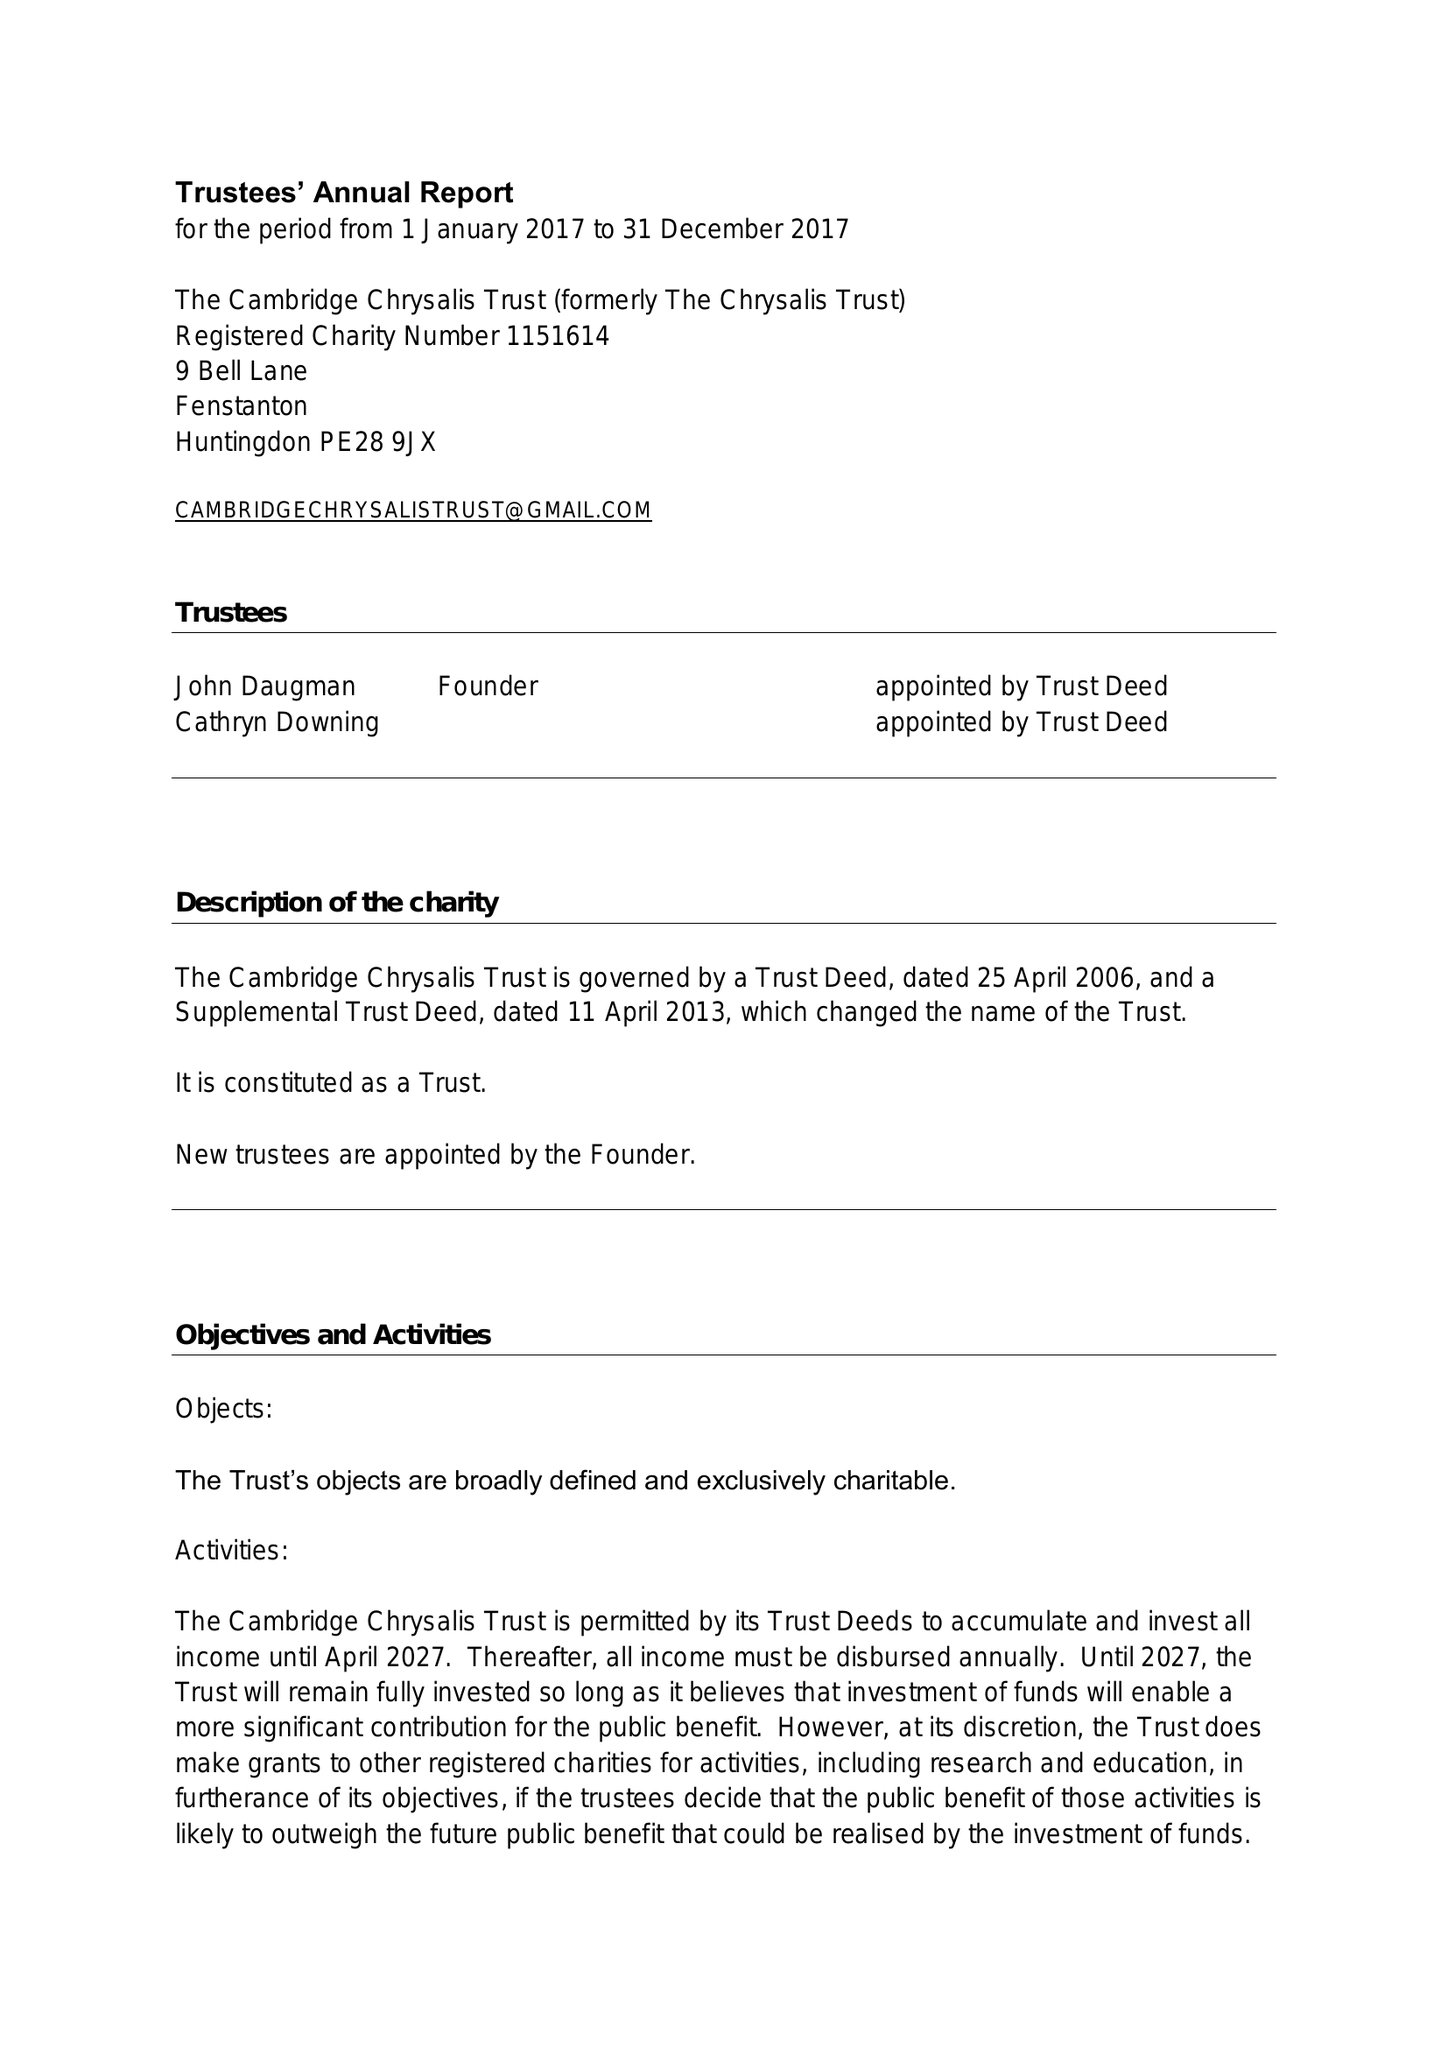What is the value for the charity_name?
Answer the question using a single word or phrase. The Cambridge Chrysalis Trust 